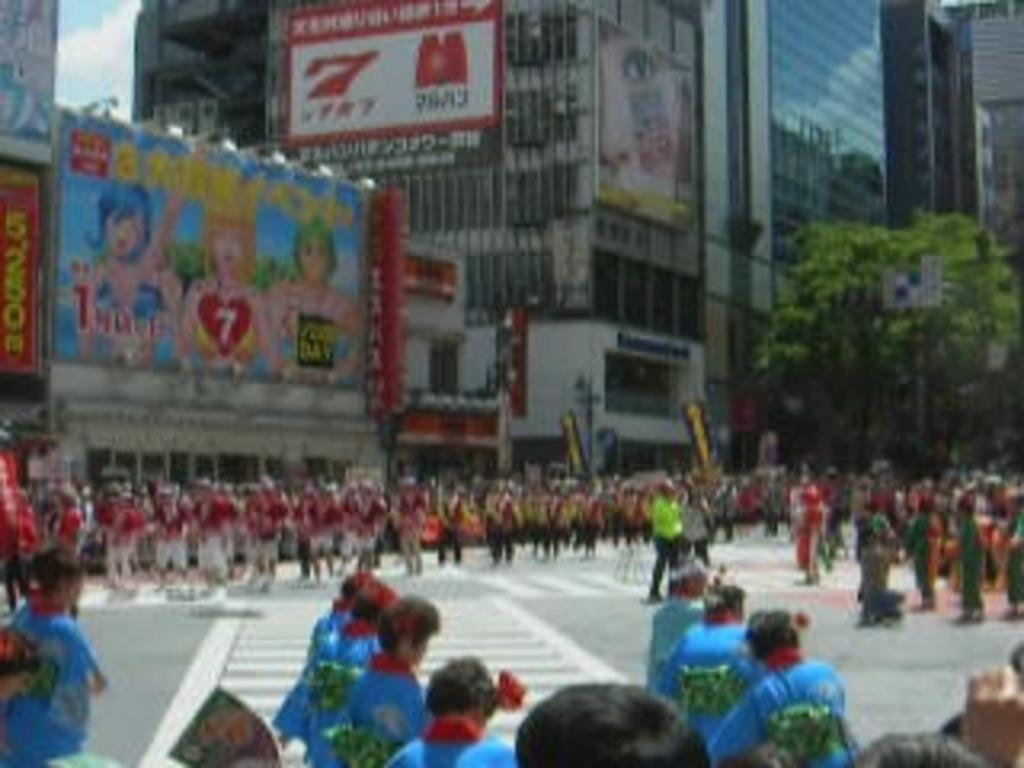What are the people in the image doing? There is a group of people standing on the road. What can be seen in the background of the image? There are buildings and a tree in the background of the image. What part of the sky is visible in the image? The sky is visible on the left side of the image. Can you hear the people's ears in the image? There is no auditory information in the image, so it is not possible to hear the people's ears. 